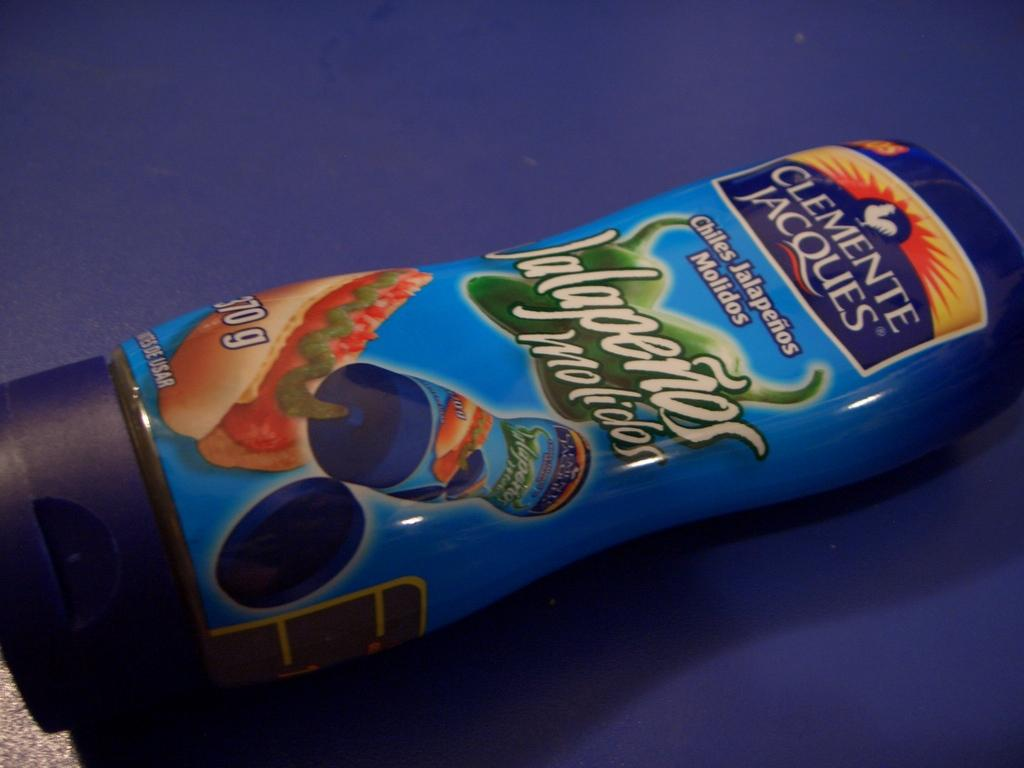<image>
Offer a succinct explanation of the picture presented. A squeesze bottle of Jalapenos on is side. 